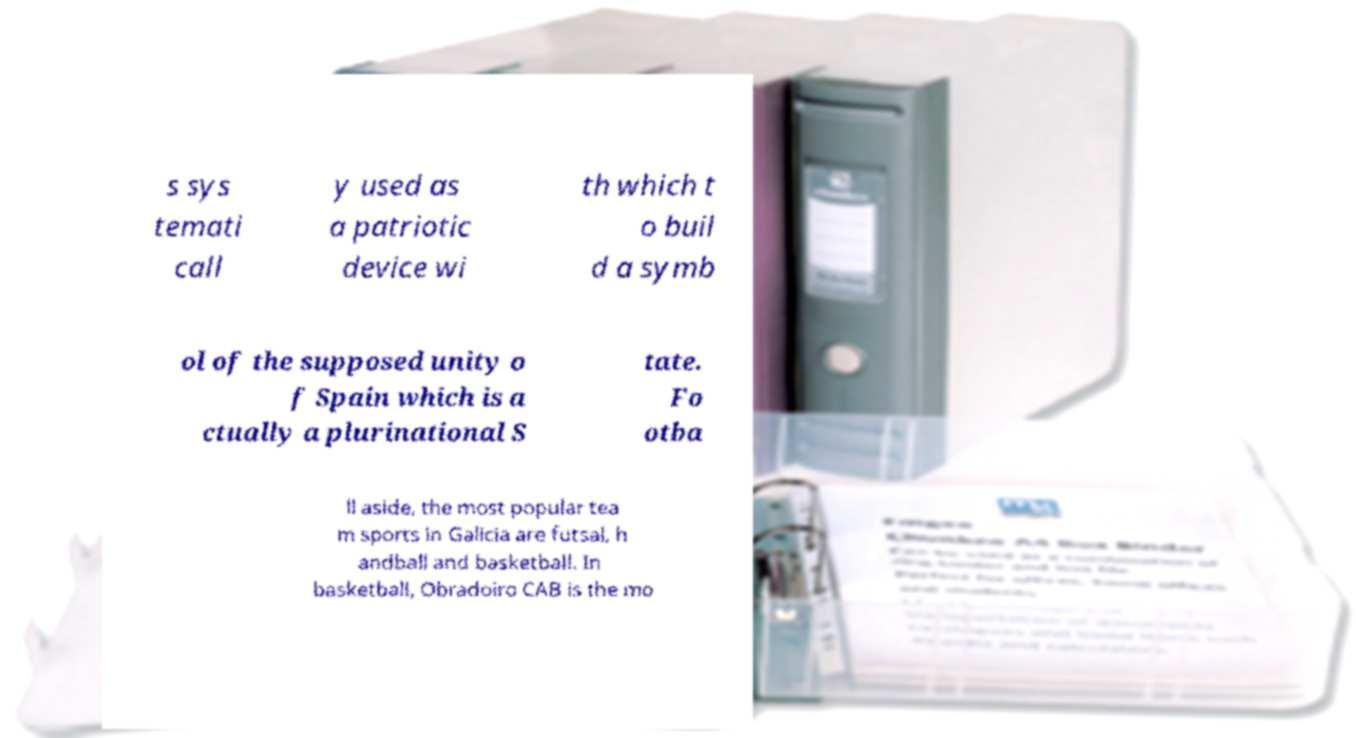Could you assist in decoding the text presented in this image and type it out clearly? s sys temati call y used as a patriotic device wi th which t o buil d a symb ol of the supposed unity o f Spain which is a ctually a plurinational S tate. Fo otba ll aside, the most popular tea m sports in Galicia are futsal, h andball and basketball. In basketball, Obradoiro CAB is the mo 